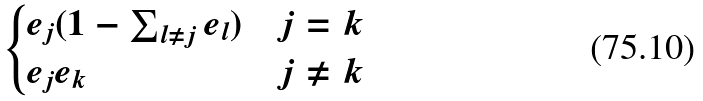Convert formula to latex. <formula><loc_0><loc_0><loc_500><loc_500>\begin{cases} e _ { j } ( 1 - \sum _ { l \ne j } e _ { l } ) & j = k \\ e _ { j } e _ { k } & j \ne k \end{cases}</formula> 